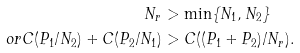Convert formula to latex. <formula><loc_0><loc_0><loc_500><loc_500>N _ { r } & > \min \{ N _ { 1 } , N _ { 2 } \} \\ o r C ( P _ { 1 } / N _ { 2 } ) + C ( P _ { 2 } / N _ { 1 } ) & > C ( ( P _ { 1 } + P _ { 2 } ) / N _ { r } ) .</formula> 